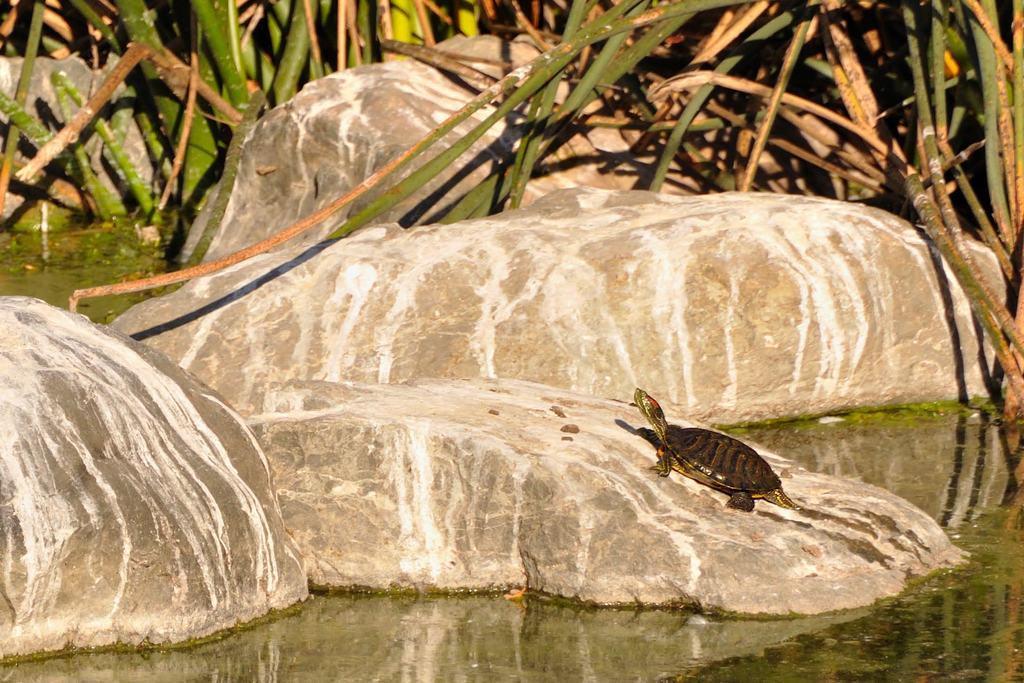Please provide a concise description of this image. In this picture there is a tortoise on the rock and at the back there are rocks and plants. At the bottom there is water. 